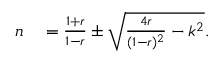<formula> <loc_0><loc_0><loc_500><loc_500>\begin{array} { r l } { n } & = \frac { 1 + r } { 1 - r } \pm \sqrt { \frac { 4 r } { ( 1 - r ) ^ { 2 } } - k ^ { 2 } } . } \end{array}</formula> 